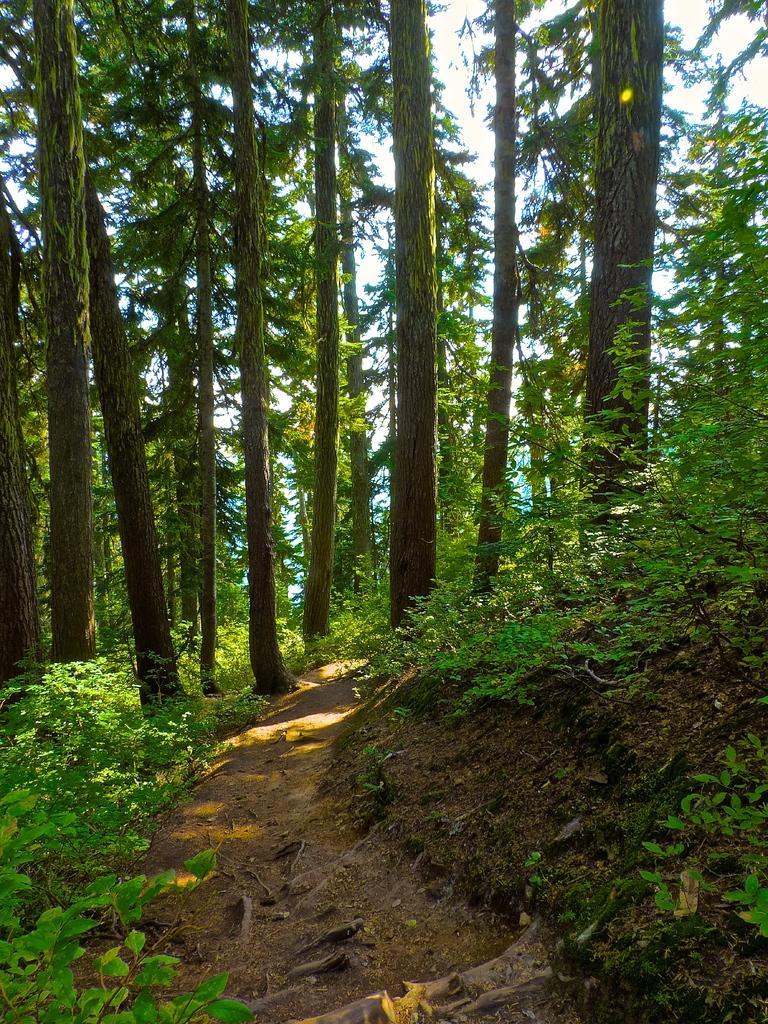Describe this image in one or two sentences. In this picture we can see plants on the ground and in the background we can see trees, sky. 